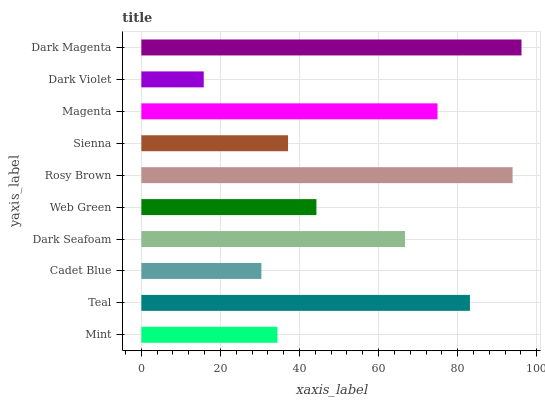Is Dark Violet the minimum?
Answer yes or no. Yes. Is Dark Magenta the maximum?
Answer yes or no. Yes. Is Teal the minimum?
Answer yes or no. No. Is Teal the maximum?
Answer yes or no. No. Is Teal greater than Mint?
Answer yes or no. Yes. Is Mint less than Teal?
Answer yes or no. Yes. Is Mint greater than Teal?
Answer yes or no. No. Is Teal less than Mint?
Answer yes or no. No. Is Dark Seafoam the high median?
Answer yes or no. Yes. Is Web Green the low median?
Answer yes or no. Yes. Is Rosy Brown the high median?
Answer yes or no. No. Is Dark Magenta the low median?
Answer yes or no. No. 